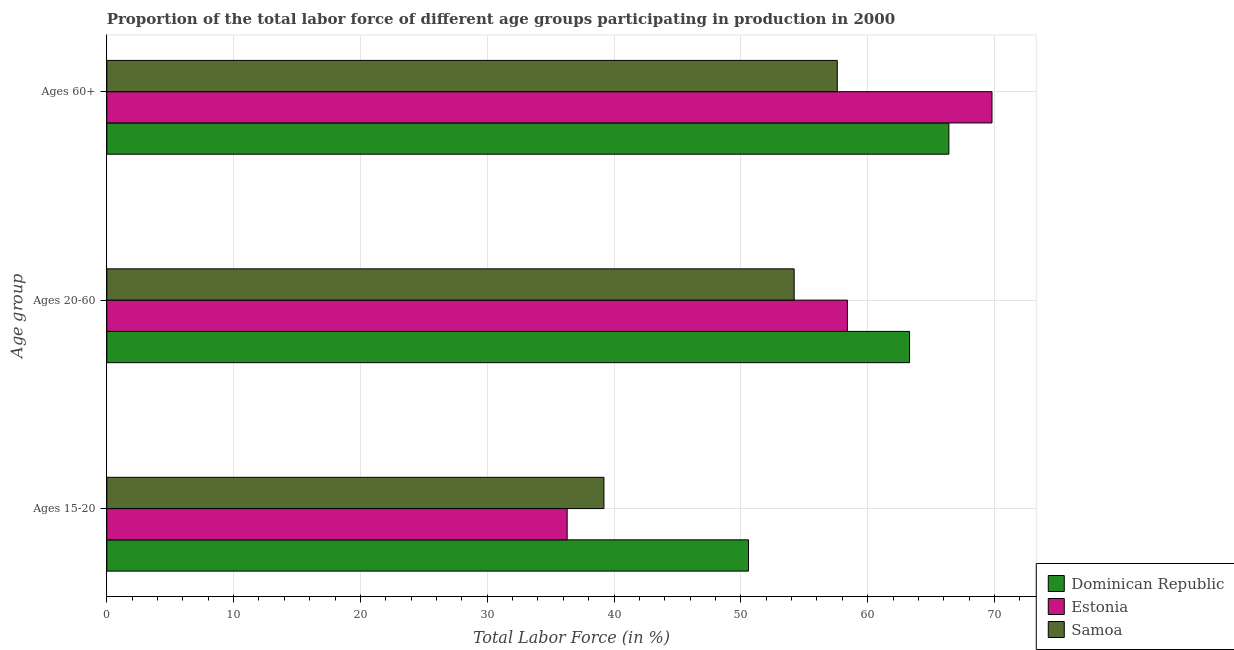How many different coloured bars are there?
Offer a very short reply. 3. Are the number of bars per tick equal to the number of legend labels?
Provide a succinct answer. Yes. How many bars are there on the 1st tick from the top?
Offer a terse response. 3. How many bars are there on the 2nd tick from the bottom?
Provide a succinct answer. 3. What is the label of the 3rd group of bars from the top?
Keep it short and to the point. Ages 15-20. What is the percentage of labor force within the age group 15-20 in Samoa?
Make the answer very short. 39.2. Across all countries, what is the maximum percentage of labor force within the age group 15-20?
Offer a terse response. 50.6. Across all countries, what is the minimum percentage of labor force above age 60?
Ensure brevity in your answer.  57.6. In which country was the percentage of labor force above age 60 maximum?
Offer a very short reply. Estonia. In which country was the percentage of labor force within the age group 20-60 minimum?
Your answer should be compact. Samoa. What is the total percentage of labor force above age 60 in the graph?
Your answer should be compact. 193.8. What is the difference between the percentage of labor force above age 60 in Estonia and that in Dominican Republic?
Your answer should be very brief. 3.4. What is the difference between the percentage of labor force within the age group 20-60 in Samoa and the percentage of labor force above age 60 in Estonia?
Give a very brief answer. -15.6. What is the average percentage of labor force within the age group 20-60 per country?
Make the answer very short. 58.63. What is the difference between the percentage of labor force within the age group 20-60 and percentage of labor force within the age group 15-20 in Dominican Republic?
Give a very brief answer. 12.7. In how many countries, is the percentage of labor force above age 60 greater than 52 %?
Provide a succinct answer. 3. What is the ratio of the percentage of labor force within the age group 15-20 in Estonia to that in Samoa?
Your answer should be compact. 0.93. What is the difference between the highest and the second highest percentage of labor force above age 60?
Ensure brevity in your answer.  3.4. What is the difference between the highest and the lowest percentage of labor force within the age group 20-60?
Your response must be concise. 9.1. What does the 3rd bar from the top in Ages 60+ represents?
Keep it short and to the point. Dominican Republic. What does the 3rd bar from the bottom in Ages 20-60 represents?
Give a very brief answer. Samoa. How many bars are there?
Your answer should be compact. 9. Are all the bars in the graph horizontal?
Your answer should be compact. Yes. Are the values on the major ticks of X-axis written in scientific E-notation?
Keep it short and to the point. No. Does the graph contain any zero values?
Offer a very short reply. No. What is the title of the graph?
Your response must be concise. Proportion of the total labor force of different age groups participating in production in 2000. Does "Chile" appear as one of the legend labels in the graph?
Keep it short and to the point. No. What is the label or title of the X-axis?
Give a very brief answer. Total Labor Force (in %). What is the label or title of the Y-axis?
Provide a succinct answer. Age group. What is the Total Labor Force (in %) of Dominican Republic in Ages 15-20?
Your answer should be very brief. 50.6. What is the Total Labor Force (in %) of Estonia in Ages 15-20?
Provide a short and direct response. 36.3. What is the Total Labor Force (in %) in Samoa in Ages 15-20?
Offer a very short reply. 39.2. What is the Total Labor Force (in %) in Dominican Republic in Ages 20-60?
Offer a very short reply. 63.3. What is the Total Labor Force (in %) in Estonia in Ages 20-60?
Keep it short and to the point. 58.4. What is the Total Labor Force (in %) in Samoa in Ages 20-60?
Keep it short and to the point. 54.2. What is the Total Labor Force (in %) in Dominican Republic in Ages 60+?
Provide a succinct answer. 66.4. What is the Total Labor Force (in %) in Estonia in Ages 60+?
Provide a short and direct response. 69.8. What is the Total Labor Force (in %) of Samoa in Ages 60+?
Make the answer very short. 57.6. Across all Age group, what is the maximum Total Labor Force (in %) of Dominican Republic?
Your answer should be compact. 66.4. Across all Age group, what is the maximum Total Labor Force (in %) of Estonia?
Your answer should be very brief. 69.8. Across all Age group, what is the maximum Total Labor Force (in %) of Samoa?
Your answer should be very brief. 57.6. Across all Age group, what is the minimum Total Labor Force (in %) in Dominican Republic?
Ensure brevity in your answer.  50.6. Across all Age group, what is the minimum Total Labor Force (in %) in Estonia?
Ensure brevity in your answer.  36.3. Across all Age group, what is the minimum Total Labor Force (in %) in Samoa?
Your answer should be compact. 39.2. What is the total Total Labor Force (in %) of Dominican Republic in the graph?
Offer a terse response. 180.3. What is the total Total Labor Force (in %) of Estonia in the graph?
Your response must be concise. 164.5. What is the total Total Labor Force (in %) in Samoa in the graph?
Your answer should be very brief. 151. What is the difference between the Total Labor Force (in %) in Estonia in Ages 15-20 and that in Ages 20-60?
Provide a short and direct response. -22.1. What is the difference between the Total Labor Force (in %) in Samoa in Ages 15-20 and that in Ages 20-60?
Offer a very short reply. -15. What is the difference between the Total Labor Force (in %) of Dominican Republic in Ages 15-20 and that in Ages 60+?
Offer a very short reply. -15.8. What is the difference between the Total Labor Force (in %) in Estonia in Ages 15-20 and that in Ages 60+?
Ensure brevity in your answer.  -33.5. What is the difference between the Total Labor Force (in %) in Samoa in Ages 15-20 and that in Ages 60+?
Offer a very short reply. -18.4. What is the difference between the Total Labor Force (in %) of Dominican Republic in Ages 20-60 and that in Ages 60+?
Your answer should be very brief. -3.1. What is the difference between the Total Labor Force (in %) in Estonia in Ages 20-60 and that in Ages 60+?
Give a very brief answer. -11.4. What is the difference between the Total Labor Force (in %) in Samoa in Ages 20-60 and that in Ages 60+?
Give a very brief answer. -3.4. What is the difference between the Total Labor Force (in %) of Estonia in Ages 15-20 and the Total Labor Force (in %) of Samoa in Ages 20-60?
Give a very brief answer. -17.9. What is the difference between the Total Labor Force (in %) in Dominican Republic in Ages 15-20 and the Total Labor Force (in %) in Estonia in Ages 60+?
Offer a very short reply. -19.2. What is the difference between the Total Labor Force (in %) of Estonia in Ages 15-20 and the Total Labor Force (in %) of Samoa in Ages 60+?
Your answer should be compact. -21.3. What is the difference between the Total Labor Force (in %) of Dominican Republic in Ages 20-60 and the Total Labor Force (in %) of Samoa in Ages 60+?
Your answer should be very brief. 5.7. What is the average Total Labor Force (in %) in Dominican Republic per Age group?
Your response must be concise. 60.1. What is the average Total Labor Force (in %) of Estonia per Age group?
Provide a short and direct response. 54.83. What is the average Total Labor Force (in %) of Samoa per Age group?
Offer a terse response. 50.33. What is the difference between the Total Labor Force (in %) of Estonia and Total Labor Force (in %) of Samoa in Ages 15-20?
Make the answer very short. -2.9. What is the difference between the Total Labor Force (in %) in Dominican Republic and Total Labor Force (in %) in Estonia in Ages 20-60?
Make the answer very short. 4.9. What is the difference between the Total Labor Force (in %) in Dominican Republic and Total Labor Force (in %) in Samoa in Ages 20-60?
Your answer should be very brief. 9.1. What is the difference between the Total Labor Force (in %) of Estonia and Total Labor Force (in %) of Samoa in Ages 60+?
Your response must be concise. 12.2. What is the ratio of the Total Labor Force (in %) in Dominican Republic in Ages 15-20 to that in Ages 20-60?
Ensure brevity in your answer.  0.8. What is the ratio of the Total Labor Force (in %) in Estonia in Ages 15-20 to that in Ages 20-60?
Provide a succinct answer. 0.62. What is the ratio of the Total Labor Force (in %) in Samoa in Ages 15-20 to that in Ages 20-60?
Provide a succinct answer. 0.72. What is the ratio of the Total Labor Force (in %) in Dominican Republic in Ages 15-20 to that in Ages 60+?
Make the answer very short. 0.76. What is the ratio of the Total Labor Force (in %) of Estonia in Ages 15-20 to that in Ages 60+?
Keep it short and to the point. 0.52. What is the ratio of the Total Labor Force (in %) of Samoa in Ages 15-20 to that in Ages 60+?
Offer a terse response. 0.68. What is the ratio of the Total Labor Force (in %) of Dominican Republic in Ages 20-60 to that in Ages 60+?
Provide a short and direct response. 0.95. What is the ratio of the Total Labor Force (in %) in Estonia in Ages 20-60 to that in Ages 60+?
Keep it short and to the point. 0.84. What is the ratio of the Total Labor Force (in %) in Samoa in Ages 20-60 to that in Ages 60+?
Your answer should be very brief. 0.94. What is the difference between the highest and the second highest Total Labor Force (in %) of Samoa?
Keep it short and to the point. 3.4. What is the difference between the highest and the lowest Total Labor Force (in %) in Dominican Republic?
Give a very brief answer. 15.8. What is the difference between the highest and the lowest Total Labor Force (in %) of Estonia?
Keep it short and to the point. 33.5. 